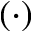Convert formula to latex. <formula><loc_0><loc_0><loc_500><loc_500>( \cdot )</formula> 